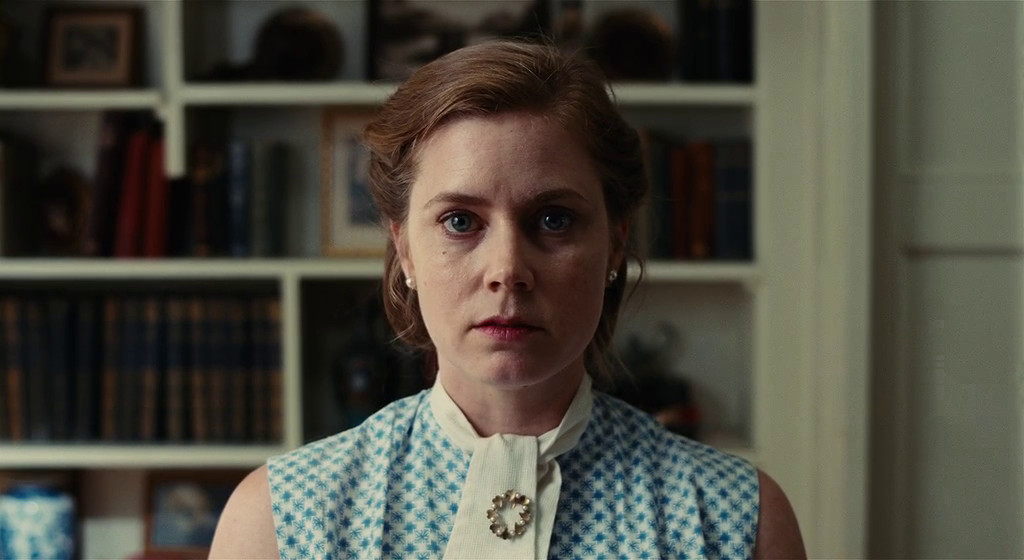What are the key elements in this picture? The image features a woman in a room filled with bookshelves, suggesting an intellectual or professional setting. She is dressed elegantly in a blue and white checkered dress complemented by a white collar, indicating a character with a keen sense of style rooted in classic fashion. A distinctive brooch at her collar adds a unique accent, hinting at personal or character significance. Her poised expression and neatly styled bun contribute to an aura of seriousness and composure, inviting viewers to consider her role in the story. 